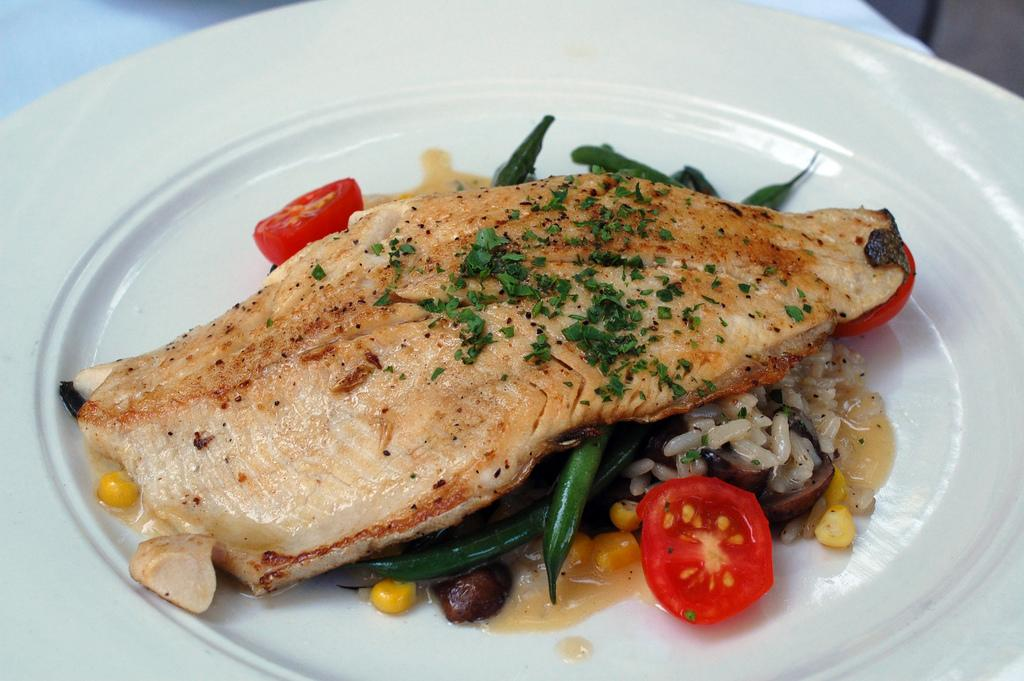What is on the plate in the image? There is food on a plate in the image. Where is the mailbox located in the image? There is no mailbox present in the image. What process is being depicted in the image? The image does not depict a process; it simply shows food on a plate. 